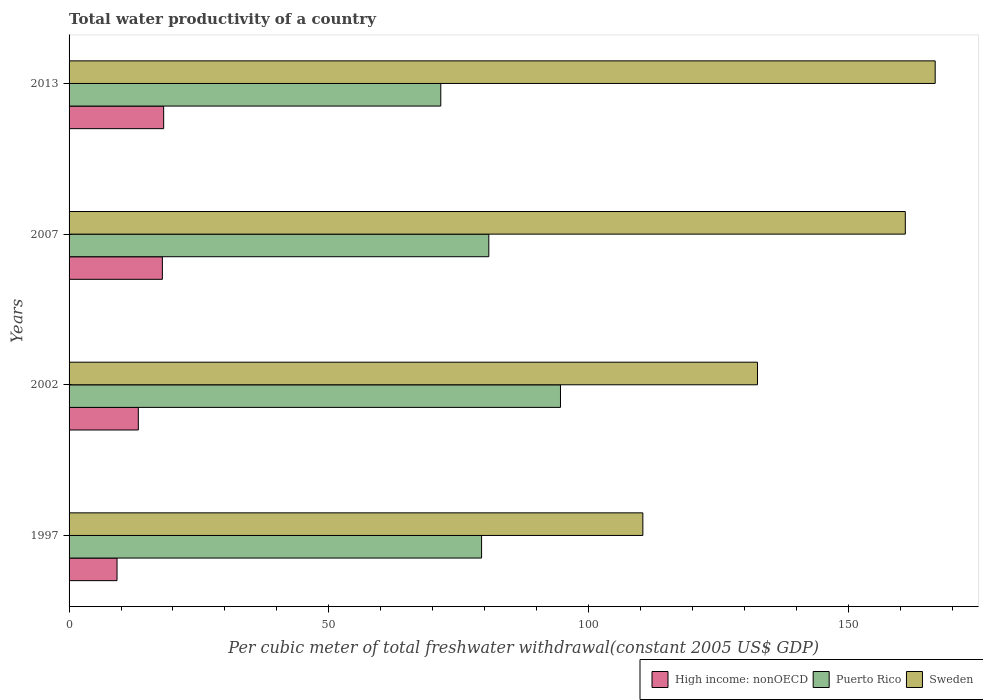How many different coloured bars are there?
Make the answer very short. 3. Are the number of bars per tick equal to the number of legend labels?
Offer a terse response. Yes. What is the total water productivity in High income: nonOECD in 2007?
Your answer should be compact. 17.96. Across all years, what is the maximum total water productivity in Sweden?
Ensure brevity in your answer.  166.74. Across all years, what is the minimum total water productivity in Puerto Rico?
Ensure brevity in your answer.  71.56. What is the total total water productivity in High income: nonOECD in the graph?
Keep it short and to the point. 58.74. What is the difference between the total water productivity in Puerto Rico in 1997 and that in 2002?
Keep it short and to the point. -15.19. What is the difference between the total water productivity in Sweden in 2013 and the total water productivity in High income: nonOECD in 2002?
Ensure brevity in your answer.  153.41. What is the average total water productivity in Sweden per year?
Keep it short and to the point. 142.68. In the year 2013, what is the difference between the total water productivity in Sweden and total water productivity in Puerto Rico?
Your response must be concise. 95.18. In how many years, is the total water productivity in Puerto Rico greater than 40 US$?
Provide a succinct answer. 4. What is the ratio of the total water productivity in Sweden in 1997 to that in 2007?
Provide a short and direct response. 0.69. Is the difference between the total water productivity in Sweden in 2002 and 2013 greater than the difference between the total water productivity in Puerto Rico in 2002 and 2013?
Your response must be concise. No. What is the difference between the highest and the second highest total water productivity in Sweden?
Offer a terse response. 5.75. What is the difference between the highest and the lowest total water productivity in Sweden?
Your answer should be very brief. 56.28. In how many years, is the total water productivity in Puerto Rico greater than the average total water productivity in Puerto Rico taken over all years?
Offer a terse response. 1. What does the 3rd bar from the top in 2013 represents?
Your response must be concise. High income: nonOECD. What does the 2nd bar from the bottom in 2007 represents?
Offer a terse response. Puerto Rico. Is it the case that in every year, the sum of the total water productivity in Puerto Rico and total water productivity in Sweden is greater than the total water productivity in High income: nonOECD?
Offer a very short reply. Yes. How many bars are there?
Give a very brief answer. 12. Are all the bars in the graph horizontal?
Offer a very short reply. Yes. What is the difference between two consecutive major ticks on the X-axis?
Offer a terse response. 50. Are the values on the major ticks of X-axis written in scientific E-notation?
Your answer should be very brief. No. Does the graph contain grids?
Your answer should be very brief. No. How are the legend labels stacked?
Ensure brevity in your answer.  Horizontal. What is the title of the graph?
Your answer should be very brief. Total water productivity of a country. Does "United States" appear as one of the legend labels in the graph?
Make the answer very short. No. What is the label or title of the X-axis?
Ensure brevity in your answer.  Per cubic meter of total freshwater withdrawal(constant 2005 US$ GDP). What is the Per cubic meter of total freshwater withdrawal(constant 2005 US$ GDP) of High income: nonOECD in 1997?
Your answer should be compact. 9.23. What is the Per cubic meter of total freshwater withdrawal(constant 2005 US$ GDP) of Puerto Rico in 1997?
Keep it short and to the point. 79.41. What is the Per cubic meter of total freshwater withdrawal(constant 2005 US$ GDP) in Sweden in 1997?
Offer a very short reply. 110.46. What is the Per cubic meter of total freshwater withdrawal(constant 2005 US$ GDP) of High income: nonOECD in 2002?
Provide a succinct answer. 13.33. What is the Per cubic meter of total freshwater withdrawal(constant 2005 US$ GDP) in Puerto Rico in 2002?
Make the answer very short. 94.61. What is the Per cubic meter of total freshwater withdrawal(constant 2005 US$ GDP) in Sweden in 2002?
Your answer should be compact. 132.53. What is the Per cubic meter of total freshwater withdrawal(constant 2005 US$ GDP) of High income: nonOECD in 2007?
Your answer should be very brief. 17.96. What is the Per cubic meter of total freshwater withdrawal(constant 2005 US$ GDP) in Puerto Rico in 2007?
Offer a terse response. 80.81. What is the Per cubic meter of total freshwater withdrawal(constant 2005 US$ GDP) in Sweden in 2007?
Give a very brief answer. 160.99. What is the Per cubic meter of total freshwater withdrawal(constant 2005 US$ GDP) in High income: nonOECD in 2013?
Provide a short and direct response. 18.21. What is the Per cubic meter of total freshwater withdrawal(constant 2005 US$ GDP) of Puerto Rico in 2013?
Your response must be concise. 71.56. What is the Per cubic meter of total freshwater withdrawal(constant 2005 US$ GDP) in Sweden in 2013?
Your answer should be compact. 166.74. Across all years, what is the maximum Per cubic meter of total freshwater withdrawal(constant 2005 US$ GDP) in High income: nonOECD?
Provide a succinct answer. 18.21. Across all years, what is the maximum Per cubic meter of total freshwater withdrawal(constant 2005 US$ GDP) of Puerto Rico?
Ensure brevity in your answer.  94.61. Across all years, what is the maximum Per cubic meter of total freshwater withdrawal(constant 2005 US$ GDP) of Sweden?
Provide a succinct answer. 166.74. Across all years, what is the minimum Per cubic meter of total freshwater withdrawal(constant 2005 US$ GDP) in High income: nonOECD?
Offer a terse response. 9.23. Across all years, what is the minimum Per cubic meter of total freshwater withdrawal(constant 2005 US$ GDP) of Puerto Rico?
Provide a short and direct response. 71.56. Across all years, what is the minimum Per cubic meter of total freshwater withdrawal(constant 2005 US$ GDP) in Sweden?
Your response must be concise. 110.46. What is the total Per cubic meter of total freshwater withdrawal(constant 2005 US$ GDP) of High income: nonOECD in the graph?
Ensure brevity in your answer.  58.74. What is the total Per cubic meter of total freshwater withdrawal(constant 2005 US$ GDP) of Puerto Rico in the graph?
Your response must be concise. 326.39. What is the total Per cubic meter of total freshwater withdrawal(constant 2005 US$ GDP) of Sweden in the graph?
Make the answer very short. 570.73. What is the difference between the Per cubic meter of total freshwater withdrawal(constant 2005 US$ GDP) in High income: nonOECD in 1997 and that in 2002?
Keep it short and to the point. -4.1. What is the difference between the Per cubic meter of total freshwater withdrawal(constant 2005 US$ GDP) of Puerto Rico in 1997 and that in 2002?
Ensure brevity in your answer.  -15.19. What is the difference between the Per cubic meter of total freshwater withdrawal(constant 2005 US$ GDP) of Sweden in 1997 and that in 2002?
Ensure brevity in your answer.  -22.07. What is the difference between the Per cubic meter of total freshwater withdrawal(constant 2005 US$ GDP) of High income: nonOECD in 1997 and that in 2007?
Your response must be concise. -8.73. What is the difference between the Per cubic meter of total freshwater withdrawal(constant 2005 US$ GDP) in Puerto Rico in 1997 and that in 2007?
Give a very brief answer. -1.39. What is the difference between the Per cubic meter of total freshwater withdrawal(constant 2005 US$ GDP) of Sweden in 1997 and that in 2007?
Your answer should be compact. -50.53. What is the difference between the Per cubic meter of total freshwater withdrawal(constant 2005 US$ GDP) in High income: nonOECD in 1997 and that in 2013?
Your response must be concise. -8.98. What is the difference between the Per cubic meter of total freshwater withdrawal(constant 2005 US$ GDP) in Puerto Rico in 1997 and that in 2013?
Provide a succinct answer. 7.85. What is the difference between the Per cubic meter of total freshwater withdrawal(constant 2005 US$ GDP) of Sweden in 1997 and that in 2013?
Ensure brevity in your answer.  -56.28. What is the difference between the Per cubic meter of total freshwater withdrawal(constant 2005 US$ GDP) of High income: nonOECD in 2002 and that in 2007?
Ensure brevity in your answer.  -4.63. What is the difference between the Per cubic meter of total freshwater withdrawal(constant 2005 US$ GDP) in Puerto Rico in 2002 and that in 2007?
Keep it short and to the point. 13.8. What is the difference between the Per cubic meter of total freshwater withdrawal(constant 2005 US$ GDP) of Sweden in 2002 and that in 2007?
Keep it short and to the point. -28.46. What is the difference between the Per cubic meter of total freshwater withdrawal(constant 2005 US$ GDP) in High income: nonOECD in 2002 and that in 2013?
Keep it short and to the point. -4.87. What is the difference between the Per cubic meter of total freshwater withdrawal(constant 2005 US$ GDP) of Puerto Rico in 2002 and that in 2013?
Provide a succinct answer. 23.05. What is the difference between the Per cubic meter of total freshwater withdrawal(constant 2005 US$ GDP) of Sweden in 2002 and that in 2013?
Give a very brief answer. -34.21. What is the difference between the Per cubic meter of total freshwater withdrawal(constant 2005 US$ GDP) in High income: nonOECD in 2007 and that in 2013?
Your response must be concise. -0.25. What is the difference between the Per cubic meter of total freshwater withdrawal(constant 2005 US$ GDP) in Puerto Rico in 2007 and that in 2013?
Offer a terse response. 9.25. What is the difference between the Per cubic meter of total freshwater withdrawal(constant 2005 US$ GDP) in Sweden in 2007 and that in 2013?
Make the answer very short. -5.75. What is the difference between the Per cubic meter of total freshwater withdrawal(constant 2005 US$ GDP) of High income: nonOECD in 1997 and the Per cubic meter of total freshwater withdrawal(constant 2005 US$ GDP) of Puerto Rico in 2002?
Provide a short and direct response. -85.37. What is the difference between the Per cubic meter of total freshwater withdrawal(constant 2005 US$ GDP) in High income: nonOECD in 1997 and the Per cubic meter of total freshwater withdrawal(constant 2005 US$ GDP) in Sweden in 2002?
Give a very brief answer. -123.3. What is the difference between the Per cubic meter of total freshwater withdrawal(constant 2005 US$ GDP) in Puerto Rico in 1997 and the Per cubic meter of total freshwater withdrawal(constant 2005 US$ GDP) in Sweden in 2002?
Give a very brief answer. -53.12. What is the difference between the Per cubic meter of total freshwater withdrawal(constant 2005 US$ GDP) in High income: nonOECD in 1997 and the Per cubic meter of total freshwater withdrawal(constant 2005 US$ GDP) in Puerto Rico in 2007?
Make the answer very short. -71.57. What is the difference between the Per cubic meter of total freshwater withdrawal(constant 2005 US$ GDP) in High income: nonOECD in 1997 and the Per cubic meter of total freshwater withdrawal(constant 2005 US$ GDP) in Sweden in 2007?
Ensure brevity in your answer.  -151.76. What is the difference between the Per cubic meter of total freshwater withdrawal(constant 2005 US$ GDP) in Puerto Rico in 1997 and the Per cubic meter of total freshwater withdrawal(constant 2005 US$ GDP) in Sweden in 2007?
Give a very brief answer. -81.58. What is the difference between the Per cubic meter of total freshwater withdrawal(constant 2005 US$ GDP) in High income: nonOECD in 1997 and the Per cubic meter of total freshwater withdrawal(constant 2005 US$ GDP) in Puerto Rico in 2013?
Provide a succinct answer. -62.33. What is the difference between the Per cubic meter of total freshwater withdrawal(constant 2005 US$ GDP) in High income: nonOECD in 1997 and the Per cubic meter of total freshwater withdrawal(constant 2005 US$ GDP) in Sweden in 2013?
Provide a succinct answer. -157.51. What is the difference between the Per cubic meter of total freshwater withdrawal(constant 2005 US$ GDP) in Puerto Rico in 1997 and the Per cubic meter of total freshwater withdrawal(constant 2005 US$ GDP) in Sweden in 2013?
Offer a terse response. -87.33. What is the difference between the Per cubic meter of total freshwater withdrawal(constant 2005 US$ GDP) in High income: nonOECD in 2002 and the Per cubic meter of total freshwater withdrawal(constant 2005 US$ GDP) in Puerto Rico in 2007?
Your answer should be compact. -67.47. What is the difference between the Per cubic meter of total freshwater withdrawal(constant 2005 US$ GDP) in High income: nonOECD in 2002 and the Per cubic meter of total freshwater withdrawal(constant 2005 US$ GDP) in Sweden in 2007?
Your answer should be compact. -147.66. What is the difference between the Per cubic meter of total freshwater withdrawal(constant 2005 US$ GDP) in Puerto Rico in 2002 and the Per cubic meter of total freshwater withdrawal(constant 2005 US$ GDP) in Sweden in 2007?
Provide a short and direct response. -66.38. What is the difference between the Per cubic meter of total freshwater withdrawal(constant 2005 US$ GDP) of High income: nonOECD in 2002 and the Per cubic meter of total freshwater withdrawal(constant 2005 US$ GDP) of Puerto Rico in 2013?
Offer a terse response. -58.23. What is the difference between the Per cubic meter of total freshwater withdrawal(constant 2005 US$ GDP) in High income: nonOECD in 2002 and the Per cubic meter of total freshwater withdrawal(constant 2005 US$ GDP) in Sweden in 2013?
Offer a terse response. -153.41. What is the difference between the Per cubic meter of total freshwater withdrawal(constant 2005 US$ GDP) of Puerto Rico in 2002 and the Per cubic meter of total freshwater withdrawal(constant 2005 US$ GDP) of Sweden in 2013?
Make the answer very short. -72.14. What is the difference between the Per cubic meter of total freshwater withdrawal(constant 2005 US$ GDP) of High income: nonOECD in 2007 and the Per cubic meter of total freshwater withdrawal(constant 2005 US$ GDP) of Puerto Rico in 2013?
Offer a very short reply. -53.6. What is the difference between the Per cubic meter of total freshwater withdrawal(constant 2005 US$ GDP) of High income: nonOECD in 2007 and the Per cubic meter of total freshwater withdrawal(constant 2005 US$ GDP) of Sweden in 2013?
Give a very brief answer. -148.78. What is the difference between the Per cubic meter of total freshwater withdrawal(constant 2005 US$ GDP) in Puerto Rico in 2007 and the Per cubic meter of total freshwater withdrawal(constant 2005 US$ GDP) in Sweden in 2013?
Ensure brevity in your answer.  -85.94. What is the average Per cubic meter of total freshwater withdrawal(constant 2005 US$ GDP) in High income: nonOECD per year?
Give a very brief answer. 14.68. What is the average Per cubic meter of total freshwater withdrawal(constant 2005 US$ GDP) of Puerto Rico per year?
Your answer should be compact. 81.6. What is the average Per cubic meter of total freshwater withdrawal(constant 2005 US$ GDP) of Sweden per year?
Your answer should be very brief. 142.68. In the year 1997, what is the difference between the Per cubic meter of total freshwater withdrawal(constant 2005 US$ GDP) in High income: nonOECD and Per cubic meter of total freshwater withdrawal(constant 2005 US$ GDP) in Puerto Rico?
Your response must be concise. -70.18. In the year 1997, what is the difference between the Per cubic meter of total freshwater withdrawal(constant 2005 US$ GDP) in High income: nonOECD and Per cubic meter of total freshwater withdrawal(constant 2005 US$ GDP) in Sweden?
Offer a terse response. -101.23. In the year 1997, what is the difference between the Per cubic meter of total freshwater withdrawal(constant 2005 US$ GDP) in Puerto Rico and Per cubic meter of total freshwater withdrawal(constant 2005 US$ GDP) in Sweden?
Make the answer very short. -31.05. In the year 2002, what is the difference between the Per cubic meter of total freshwater withdrawal(constant 2005 US$ GDP) of High income: nonOECD and Per cubic meter of total freshwater withdrawal(constant 2005 US$ GDP) of Puerto Rico?
Give a very brief answer. -81.27. In the year 2002, what is the difference between the Per cubic meter of total freshwater withdrawal(constant 2005 US$ GDP) in High income: nonOECD and Per cubic meter of total freshwater withdrawal(constant 2005 US$ GDP) in Sweden?
Your response must be concise. -119.2. In the year 2002, what is the difference between the Per cubic meter of total freshwater withdrawal(constant 2005 US$ GDP) in Puerto Rico and Per cubic meter of total freshwater withdrawal(constant 2005 US$ GDP) in Sweden?
Make the answer very short. -37.93. In the year 2007, what is the difference between the Per cubic meter of total freshwater withdrawal(constant 2005 US$ GDP) of High income: nonOECD and Per cubic meter of total freshwater withdrawal(constant 2005 US$ GDP) of Puerto Rico?
Offer a terse response. -62.84. In the year 2007, what is the difference between the Per cubic meter of total freshwater withdrawal(constant 2005 US$ GDP) of High income: nonOECD and Per cubic meter of total freshwater withdrawal(constant 2005 US$ GDP) of Sweden?
Provide a short and direct response. -143.03. In the year 2007, what is the difference between the Per cubic meter of total freshwater withdrawal(constant 2005 US$ GDP) in Puerto Rico and Per cubic meter of total freshwater withdrawal(constant 2005 US$ GDP) in Sweden?
Your response must be concise. -80.18. In the year 2013, what is the difference between the Per cubic meter of total freshwater withdrawal(constant 2005 US$ GDP) in High income: nonOECD and Per cubic meter of total freshwater withdrawal(constant 2005 US$ GDP) in Puerto Rico?
Give a very brief answer. -53.35. In the year 2013, what is the difference between the Per cubic meter of total freshwater withdrawal(constant 2005 US$ GDP) of High income: nonOECD and Per cubic meter of total freshwater withdrawal(constant 2005 US$ GDP) of Sweden?
Provide a succinct answer. -148.53. In the year 2013, what is the difference between the Per cubic meter of total freshwater withdrawal(constant 2005 US$ GDP) in Puerto Rico and Per cubic meter of total freshwater withdrawal(constant 2005 US$ GDP) in Sweden?
Offer a very short reply. -95.18. What is the ratio of the Per cubic meter of total freshwater withdrawal(constant 2005 US$ GDP) of High income: nonOECD in 1997 to that in 2002?
Provide a short and direct response. 0.69. What is the ratio of the Per cubic meter of total freshwater withdrawal(constant 2005 US$ GDP) of Puerto Rico in 1997 to that in 2002?
Ensure brevity in your answer.  0.84. What is the ratio of the Per cubic meter of total freshwater withdrawal(constant 2005 US$ GDP) of Sweden in 1997 to that in 2002?
Ensure brevity in your answer.  0.83. What is the ratio of the Per cubic meter of total freshwater withdrawal(constant 2005 US$ GDP) of High income: nonOECD in 1997 to that in 2007?
Ensure brevity in your answer.  0.51. What is the ratio of the Per cubic meter of total freshwater withdrawal(constant 2005 US$ GDP) in Puerto Rico in 1997 to that in 2007?
Provide a succinct answer. 0.98. What is the ratio of the Per cubic meter of total freshwater withdrawal(constant 2005 US$ GDP) in Sweden in 1997 to that in 2007?
Ensure brevity in your answer.  0.69. What is the ratio of the Per cubic meter of total freshwater withdrawal(constant 2005 US$ GDP) of High income: nonOECD in 1997 to that in 2013?
Make the answer very short. 0.51. What is the ratio of the Per cubic meter of total freshwater withdrawal(constant 2005 US$ GDP) of Puerto Rico in 1997 to that in 2013?
Offer a very short reply. 1.11. What is the ratio of the Per cubic meter of total freshwater withdrawal(constant 2005 US$ GDP) in Sweden in 1997 to that in 2013?
Ensure brevity in your answer.  0.66. What is the ratio of the Per cubic meter of total freshwater withdrawal(constant 2005 US$ GDP) of High income: nonOECD in 2002 to that in 2007?
Keep it short and to the point. 0.74. What is the ratio of the Per cubic meter of total freshwater withdrawal(constant 2005 US$ GDP) of Puerto Rico in 2002 to that in 2007?
Offer a terse response. 1.17. What is the ratio of the Per cubic meter of total freshwater withdrawal(constant 2005 US$ GDP) in Sweden in 2002 to that in 2007?
Ensure brevity in your answer.  0.82. What is the ratio of the Per cubic meter of total freshwater withdrawal(constant 2005 US$ GDP) of High income: nonOECD in 2002 to that in 2013?
Your answer should be very brief. 0.73. What is the ratio of the Per cubic meter of total freshwater withdrawal(constant 2005 US$ GDP) in Puerto Rico in 2002 to that in 2013?
Offer a terse response. 1.32. What is the ratio of the Per cubic meter of total freshwater withdrawal(constant 2005 US$ GDP) in Sweden in 2002 to that in 2013?
Provide a succinct answer. 0.79. What is the ratio of the Per cubic meter of total freshwater withdrawal(constant 2005 US$ GDP) in High income: nonOECD in 2007 to that in 2013?
Provide a short and direct response. 0.99. What is the ratio of the Per cubic meter of total freshwater withdrawal(constant 2005 US$ GDP) of Puerto Rico in 2007 to that in 2013?
Make the answer very short. 1.13. What is the ratio of the Per cubic meter of total freshwater withdrawal(constant 2005 US$ GDP) in Sweden in 2007 to that in 2013?
Offer a very short reply. 0.97. What is the difference between the highest and the second highest Per cubic meter of total freshwater withdrawal(constant 2005 US$ GDP) in High income: nonOECD?
Your answer should be very brief. 0.25. What is the difference between the highest and the second highest Per cubic meter of total freshwater withdrawal(constant 2005 US$ GDP) in Puerto Rico?
Your answer should be very brief. 13.8. What is the difference between the highest and the second highest Per cubic meter of total freshwater withdrawal(constant 2005 US$ GDP) of Sweden?
Your answer should be very brief. 5.75. What is the difference between the highest and the lowest Per cubic meter of total freshwater withdrawal(constant 2005 US$ GDP) of High income: nonOECD?
Provide a succinct answer. 8.98. What is the difference between the highest and the lowest Per cubic meter of total freshwater withdrawal(constant 2005 US$ GDP) in Puerto Rico?
Your answer should be very brief. 23.05. What is the difference between the highest and the lowest Per cubic meter of total freshwater withdrawal(constant 2005 US$ GDP) in Sweden?
Keep it short and to the point. 56.28. 